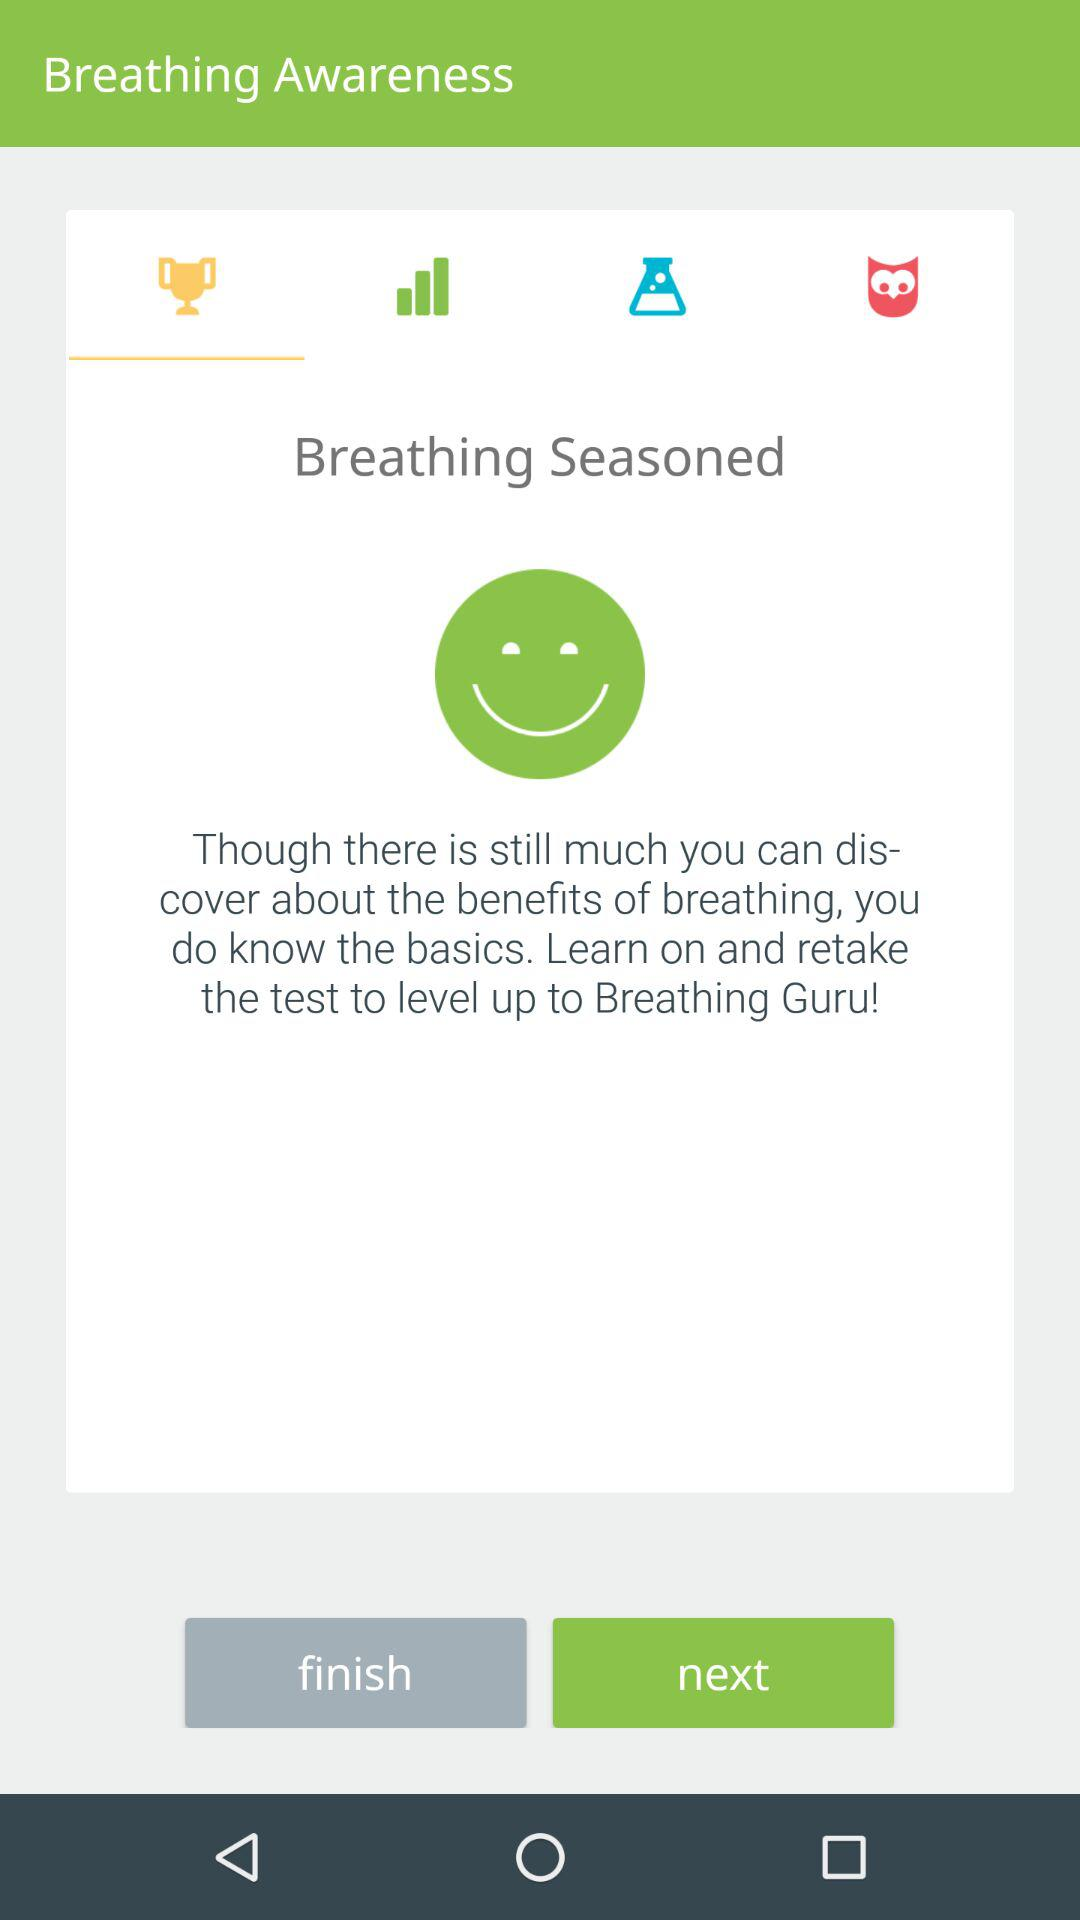What is the application Name?
When the provided information is insufficient, respond with <no answer>. <no answer> 